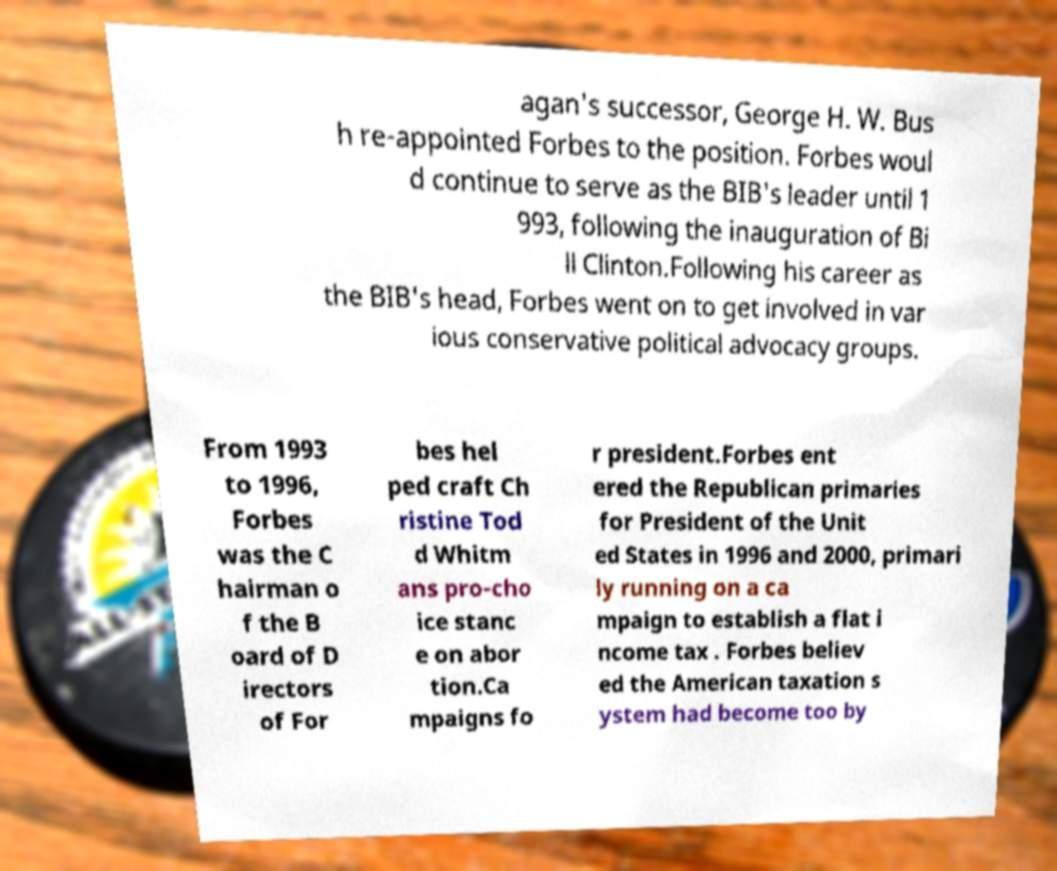Could you extract and type out the text from this image? agan's successor, George H. W. Bus h re-appointed Forbes to the position. Forbes woul d continue to serve as the BIB's leader until 1 993, following the inauguration of Bi ll Clinton.Following his career as the BIB's head, Forbes went on to get involved in var ious conservative political advocacy groups. From 1993 to 1996, Forbes was the C hairman o f the B oard of D irectors of For bes hel ped craft Ch ristine Tod d Whitm ans pro-cho ice stanc e on abor tion.Ca mpaigns fo r president.Forbes ent ered the Republican primaries for President of the Unit ed States in 1996 and 2000, primari ly running on a ca mpaign to establish a flat i ncome tax . Forbes believ ed the American taxation s ystem had become too by 